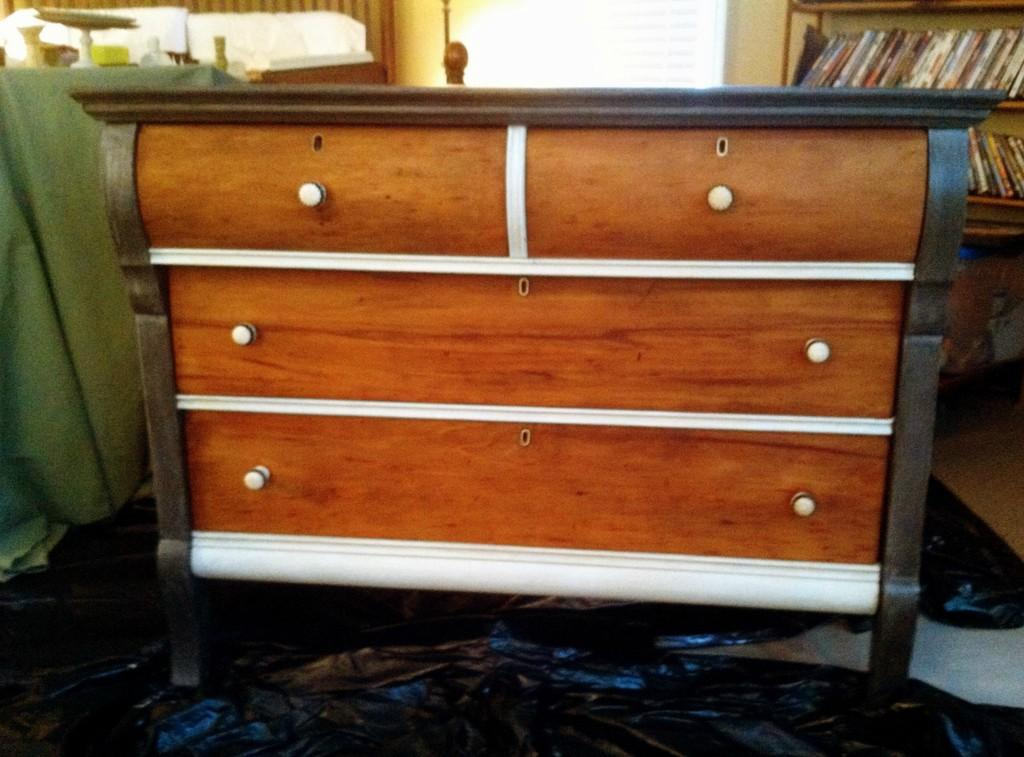What is the main object in the center of the image? There is a wooden cupboard at the center of the image. What feature does the wooden cupboard have? The wooden cupboard has a rack. What is stored on the rack? The rack is stored with books. What can be seen in the background of the image? There is a wall in the background of the image. What type of grain is stored in the wooden cupboard in the image? There is no grain stored in the wooden cupboard in the image; it is filled with books. 